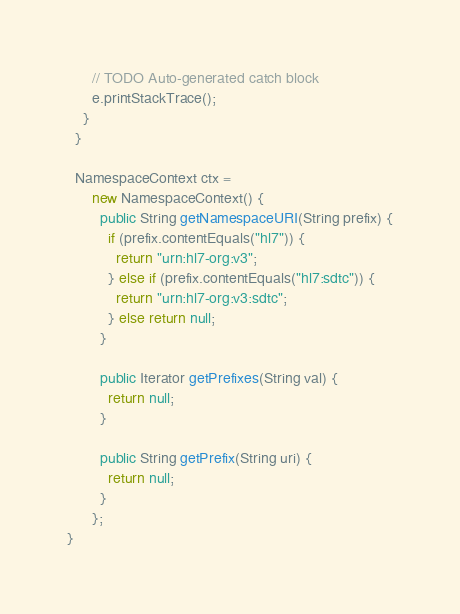<code> <loc_0><loc_0><loc_500><loc_500><_Java_>      // TODO Auto-generated catch block
      e.printStackTrace();
    }
  }

  NamespaceContext ctx =
      new NamespaceContext() {
        public String getNamespaceURI(String prefix) {
          if (prefix.contentEquals("hl7")) {
            return "urn:hl7-org:v3";
          } else if (prefix.contentEquals("hl7:sdtc")) {
            return "urn:hl7-org:v3:sdtc";
          } else return null;
        }

        public Iterator getPrefixes(String val) {
          return null;
        }

        public String getPrefix(String uri) {
          return null;
        }
      };
}
</code> 